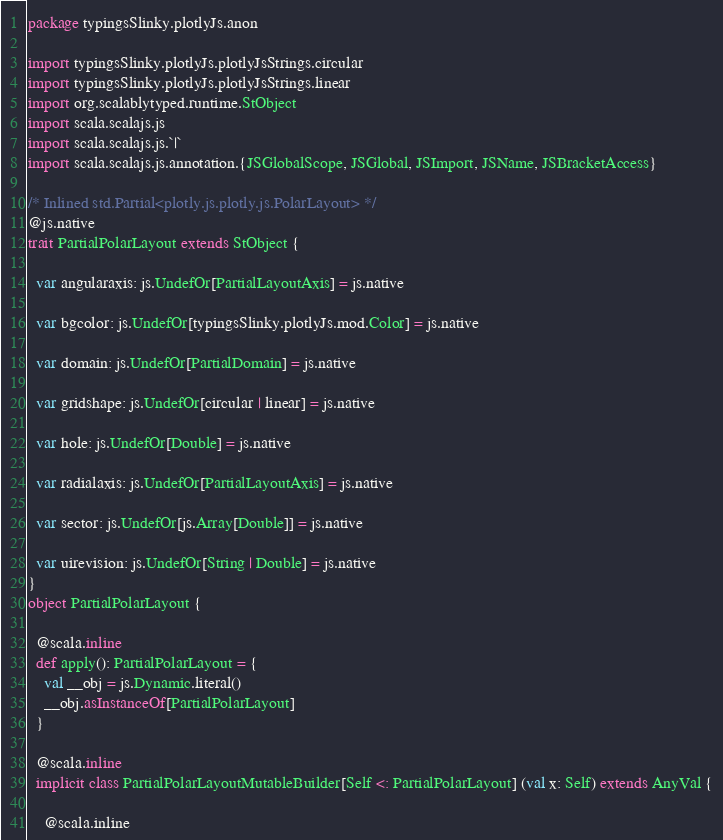Convert code to text. <code><loc_0><loc_0><loc_500><loc_500><_Scala_>package typingsSlinky.plotlyJs.anon

import typingsSlinky.plotlyJs.plotlyJsStrings.circular
import typingsSlinky.plotlyJs.plotlyJsStrings.linear
import org.scalablytyped.runtime.StObject
import scala.scalajs.js
import scala.scalajs.js.`|`
import scala.scalajs.js.annotation.{JSGlobalScope, JSGlobal, JSImport, JSName, JSBracketAccess}

/* Inlined std.Partial<plotly.js.plotly.js.PolarLayout> */
@js.native
trait PartialPolarLayout extends StObject {
  
  var angularaxis: js.UndefOr[PartialLayoutAxis] = js.native
  
  var bgcolor: js.UndefOr[typingsSlinky.plotlyJs.mod.Color] = js.native
  
  var domain: js.UndefOr[PartialDomain] = js.native
  
  var gridshape: js.UndefOr[circular | linear] = js.native
  
  var hole: js.UndefOr[Double] = js.native
  
  var radialaxis: js.UndefOr[PartialLayoutAxis] = js.native
  
  var sector: js.UndefOr[js.Array[Double]] = js.native
  
  var uirevision: js.UndefOr[String | Double] = js.native
}
object PartialPolarLayout {
  
  @scala.inline
  def apply(): PartialPolarLayout = {
    val __obj = js.Dynamic.literal()
    __obj.asInstanceOf[PartialPolarLayout]
  }
  
  @scala.inline
  implicit class PartialPolarLayoutMutableBuilder[Self <: PartialPolarLayout] (val x: Self) extends AnyVal {
    
    @scala.inline</code> 